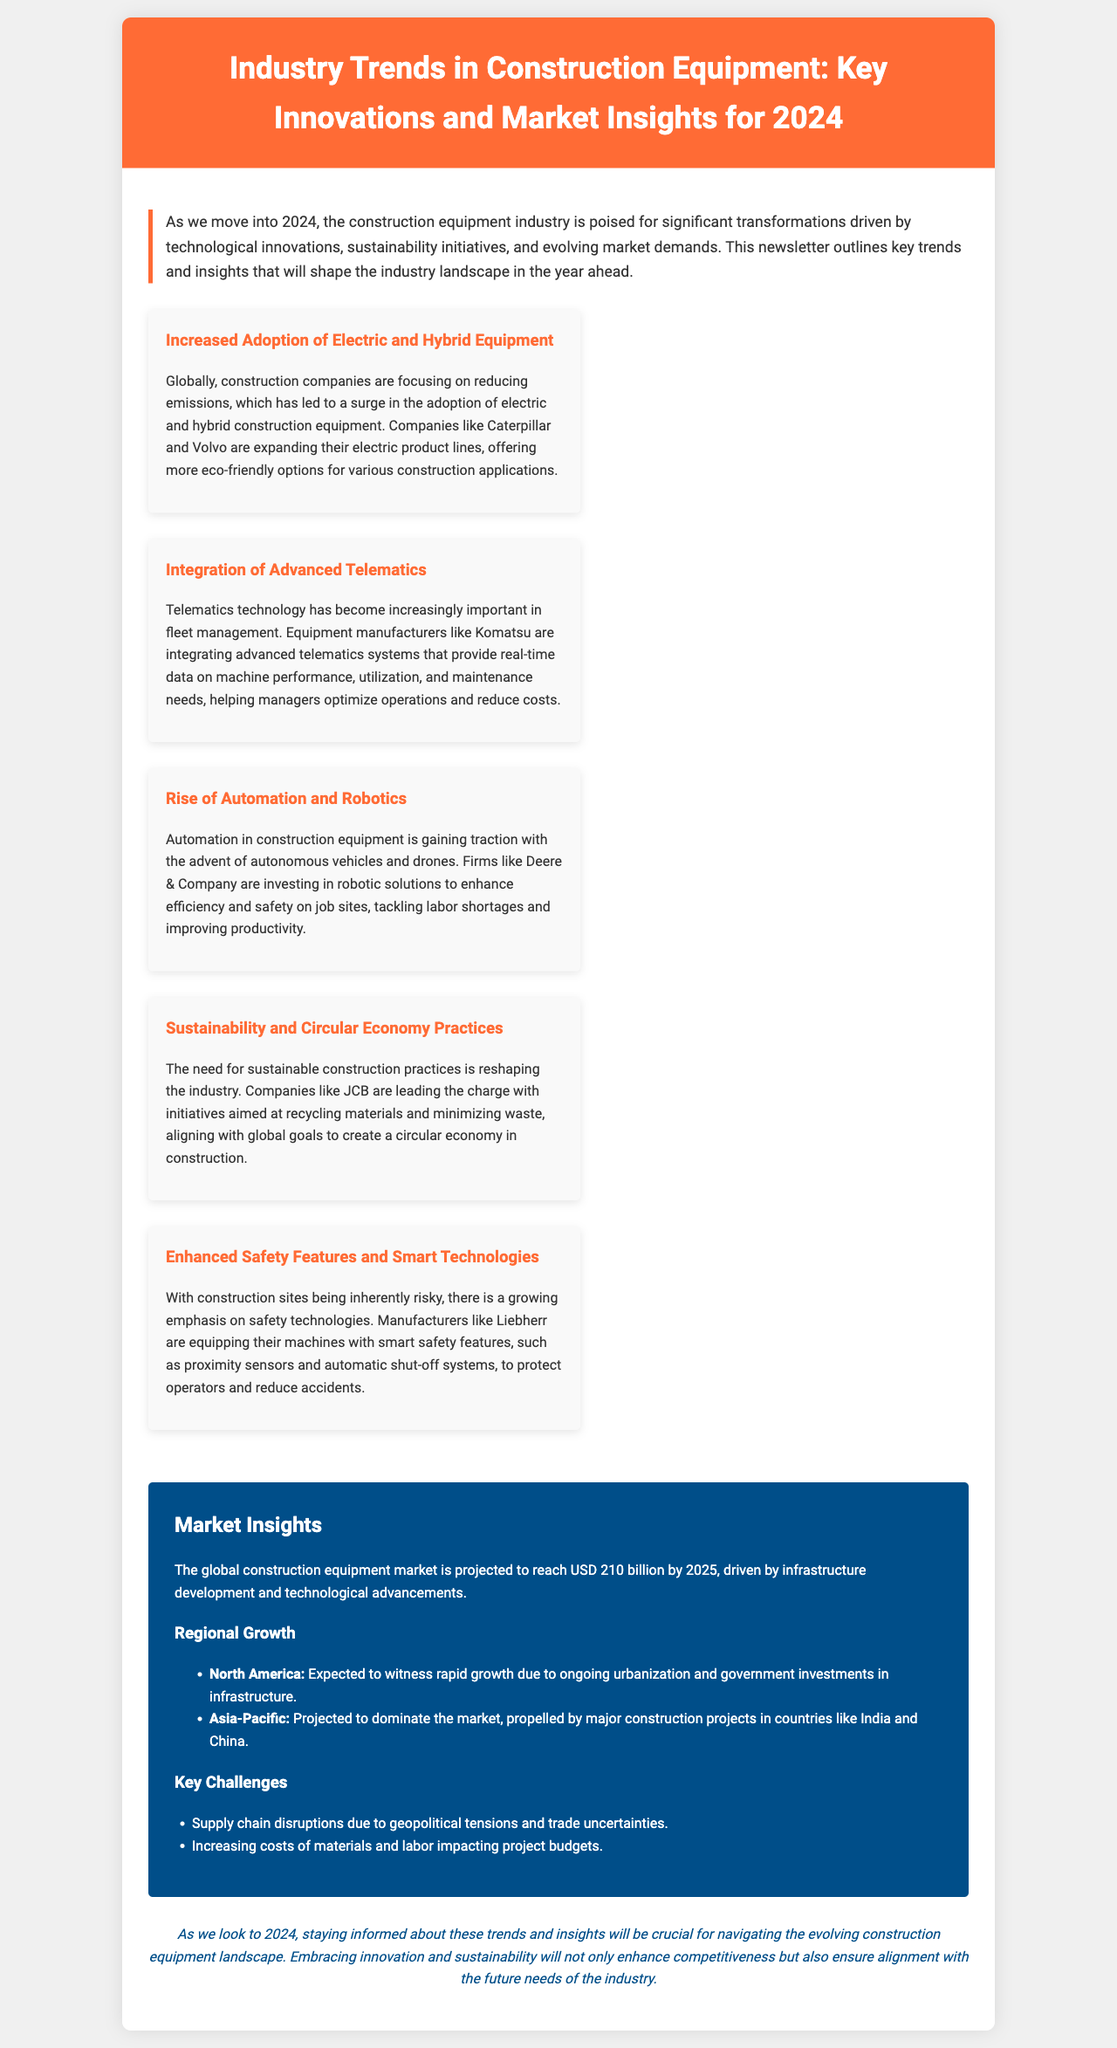What is the title of the newsletter? The title is mentioned prominently at the top of the document, which reads "Industry Trends in Construction Equipment: Key Innovations and Market Insights for 2024."
Answer: Industry Trends in Construction Equipment: Key Innovations and Market Insights for 2024 Which company is expanding its electric product lines? The document states that companies like Caterpillar and Volvo are expanding their electric product lines in response to global emissions reduction efforts.
Answer: Caterpillar and Volvo What is the projected value of the global construction equipment market by 2025? The newsletter provides a specific figure for the market projection, indicating it is expected to reach USD 210 billion.
Answer: USD 210 billion What trend focuses on real-time data for machine performance? The document highlights the significance of telematics technology in managing fleet operations, specifically mentioning advanced telematics systems.
Answer: Advanced Telematics Which region is projected to dominate the market? The newsletter details that the Asia-Pacific region is projected to dominate the construction equipment market, particularly due to significant projects in India and China.
Answer: Asia-Pacific What are construction companies doing to tackle labor shortages? The response refers to automation and robotics, which are highlighted in the trends section as solutions to enhance efficiency and safety in construction.
Answer: Automation and Robotics What safety feature is being equipped in machines by Liebherr? The newsletter mentions that Liebherr is adding smart safety features like proximity sensors and automatic shut-off systems to their machines.
Answer: Proximity sensors and automatic shut-off systems What is a key challenge faced by the construction industry? A challenge outlined in the document includes supply chain disruptions, which stem from geopolitical tensions and trade uncertainties.
Answer: Supply chain disruptions What best describes the document type? Considering the content and style, the document is designed to provide insights and updates relevant to a specific industry, typical of a newsletter format.
Answer: Newsletter 